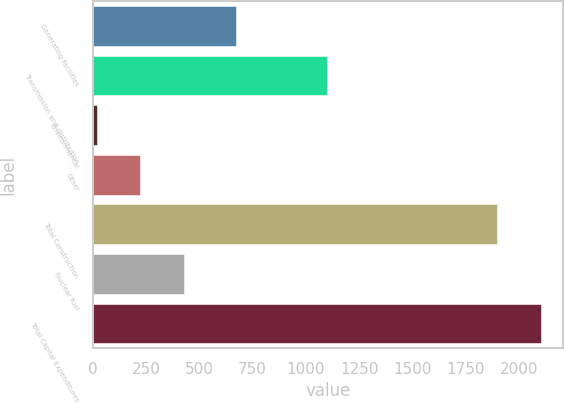Convert chart. <chart><loc_0><loc_0><loc_500><loc_500><bar_chart><fcel>Generating facilities<fcel>Transmission and distribution<fcel>Environmental<fcel>Other<fcel>Total Construction<fcel>Nuclear fuel<fcel>Total Capital Expenditures<nl><fcel>673<fcel>1097<fcel>19<fcel>224<fcel>1896<fcel>429<fcel>2101<nl></chart> 